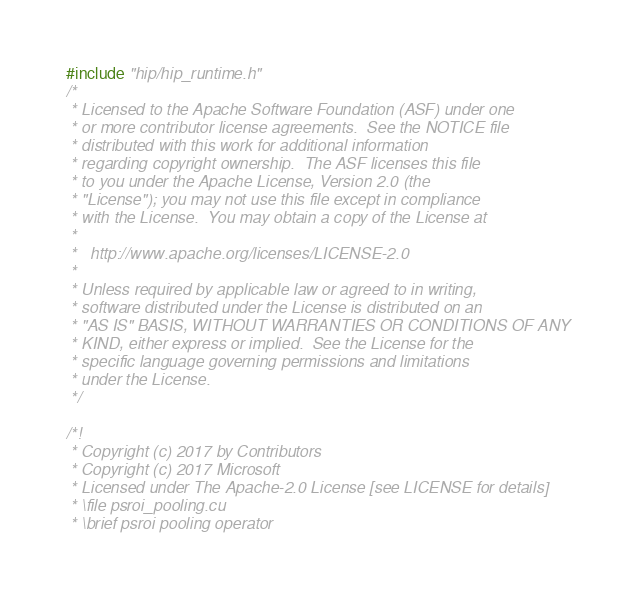<code> <loc_0><loc_0><loc_500><loc_500><_Cuda_>#include "hip/hip_runtime.h"
/*
 * Licensed to the Apache Software Foundation (ASF) under one
 * or more contributor license agreements.  See the NOTICE file
 * distributed with this work for additional information
 * regarding copyright ownership.  The ASF licenses this file
 * to you under the Apache License, Version 2.0 (the
 * "License"); you may not use this file except in compliance
 * with the License.  You may obtain a copy of the License at
 *
 *   http://www.apache.org/licenses/LICENSE-2.0
 *
 * Unless required by applicable law or agreed to in writing,
 * software distributed under the License is distributed on an
 * "AS IS" BASIS, WITHOUT WARRANTIES OR CONDITIONS OF ANY
 * KIND, either express or implied.  See the License for the
 * specific language governing permissions and limitations
 * under the License.
 */

/*!
 * Copyright (c) 2017 by Contributors
 * Copyright (c) 2017 Microsoft
 * Licensed under The Apache-2.0 License [see LICENSE for details]
 * \file psroi_pooling.cu
 * \brief psroi pooling operator</code> 